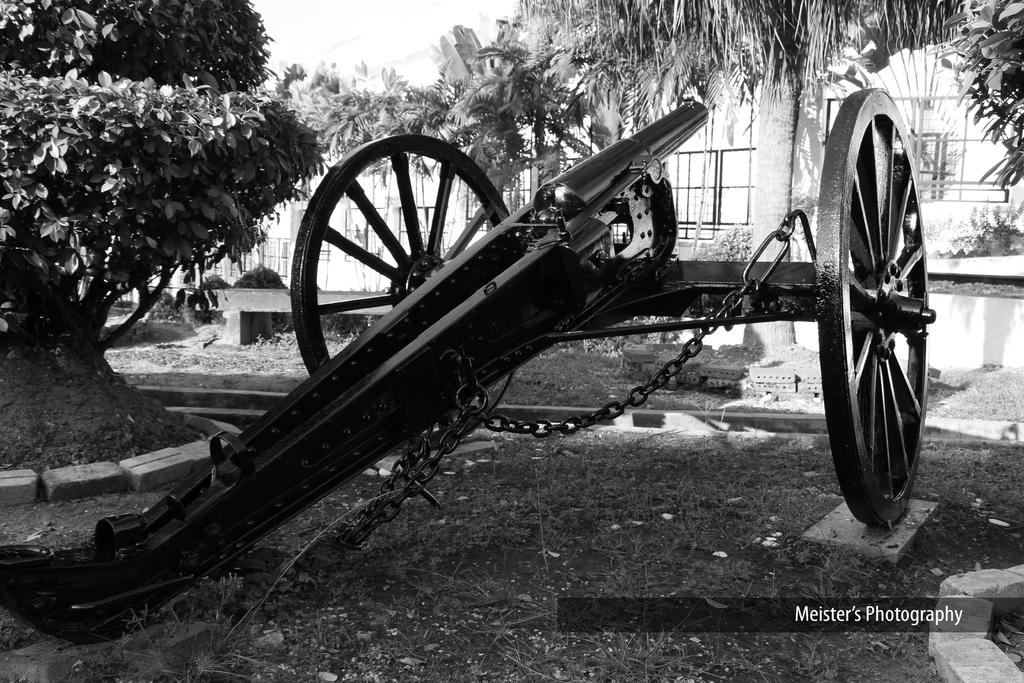What is the color scheme of the image? The image is black and white. What is the main object in the image? There is a cannon in the image. What type of natural environment is depicted in the image? There is grass, trees, and plants in the image. What type of seating is present in the image? There is a bench in the image. Is there any text or marking in the image? There is a watermark in the bottom right side of the image. What type of crime is being committed in the image? There is no crime being committed in the image; it is a still image of a cannon, grass, trees, plants, a bench, and a watermark. What is the tax rate for the area depicted in the image? There is no information about tax rates in the image; it is a still image of a cannon, grass, trees, plants, a bench, and a watermark. 